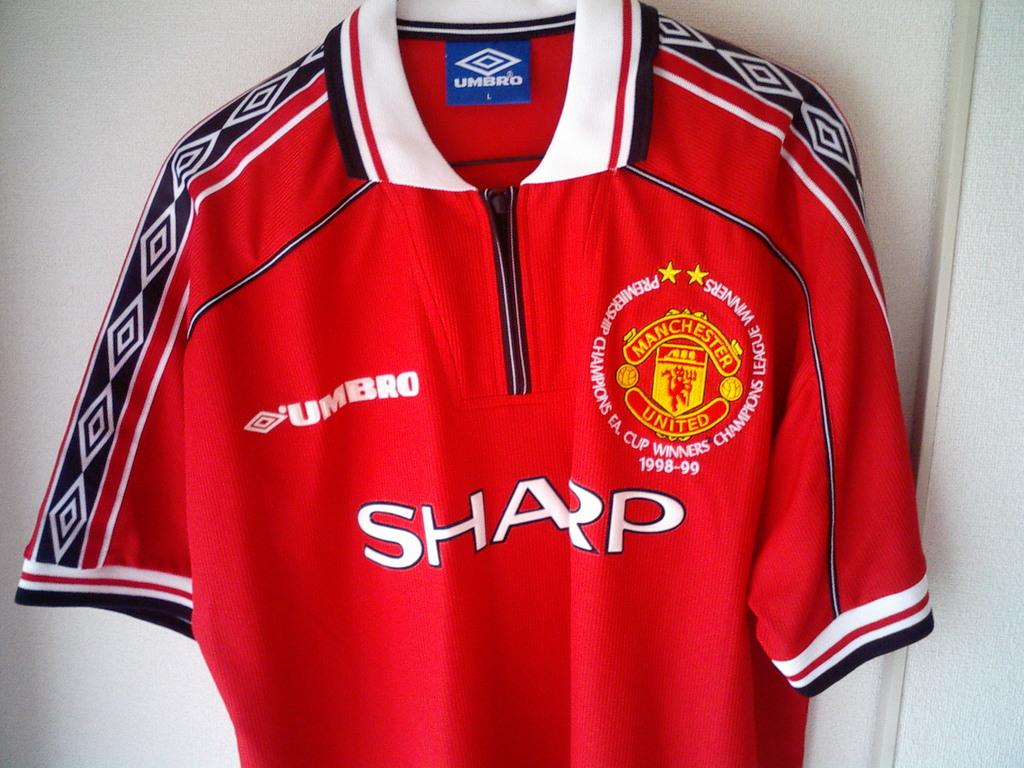<image>
Summarize the visual content of the image. a jersey that has the word Sharp on the front 